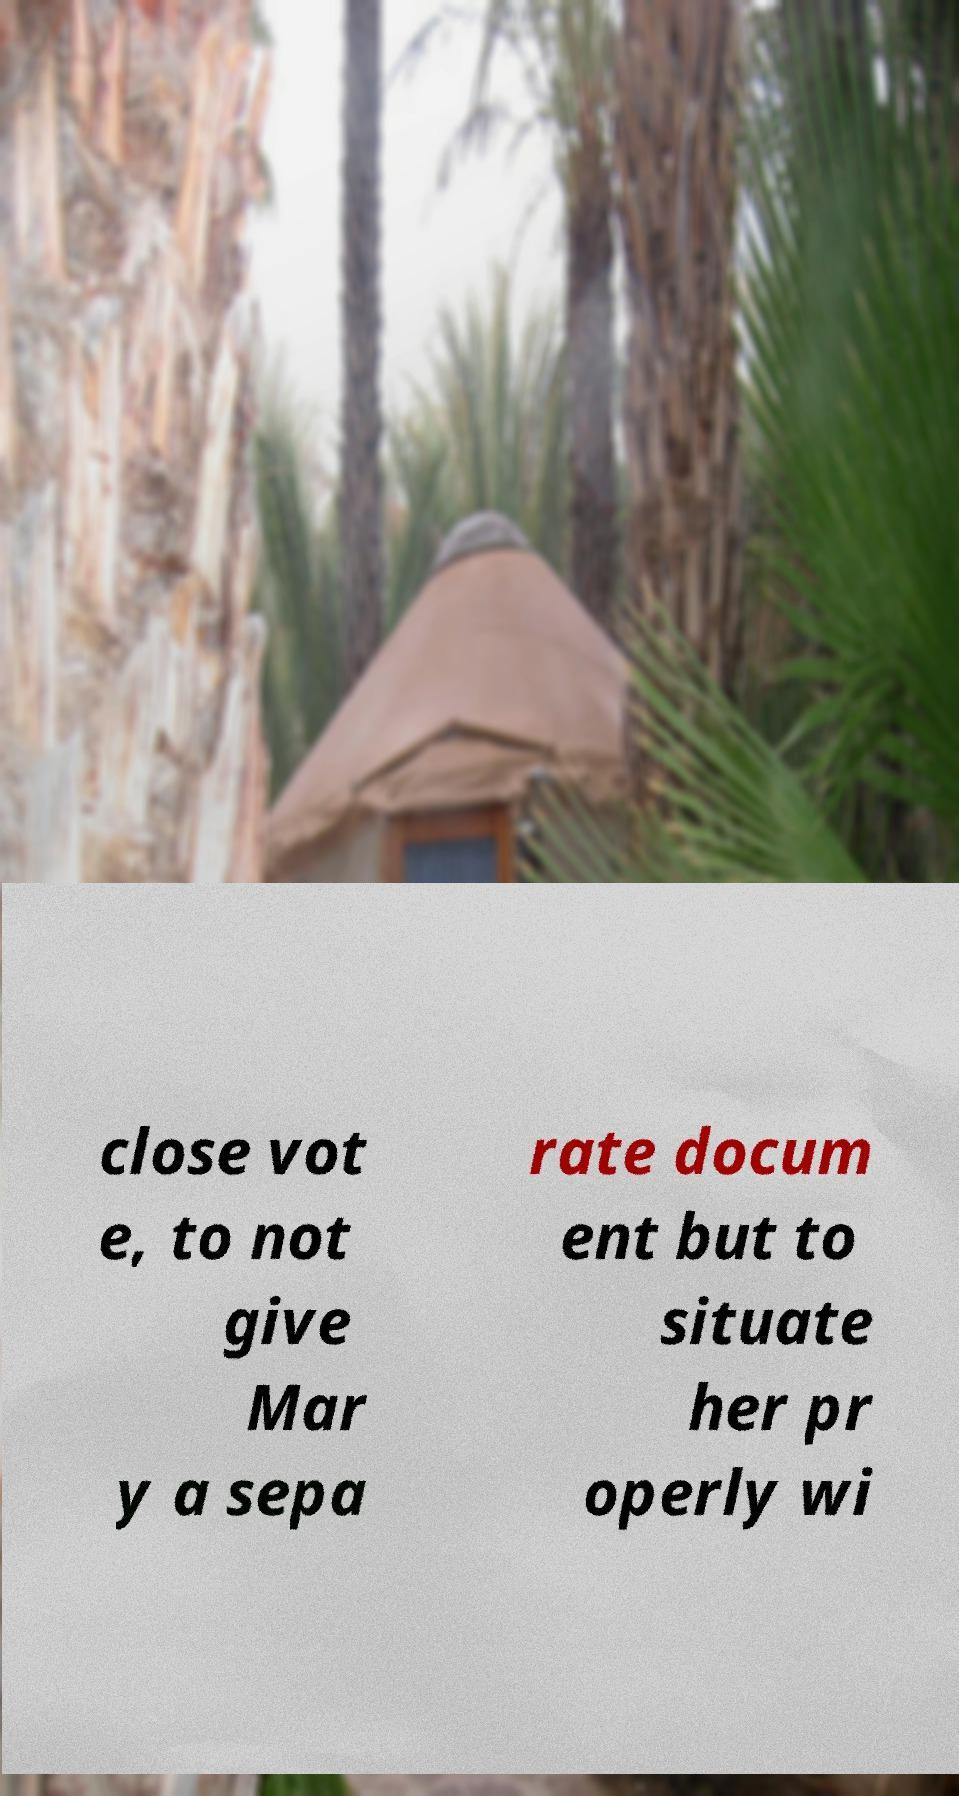Could you extract and type out the text from this image? close vot e, to not give Mar y a sepa rate docum ent but to situate her pr operly wi 